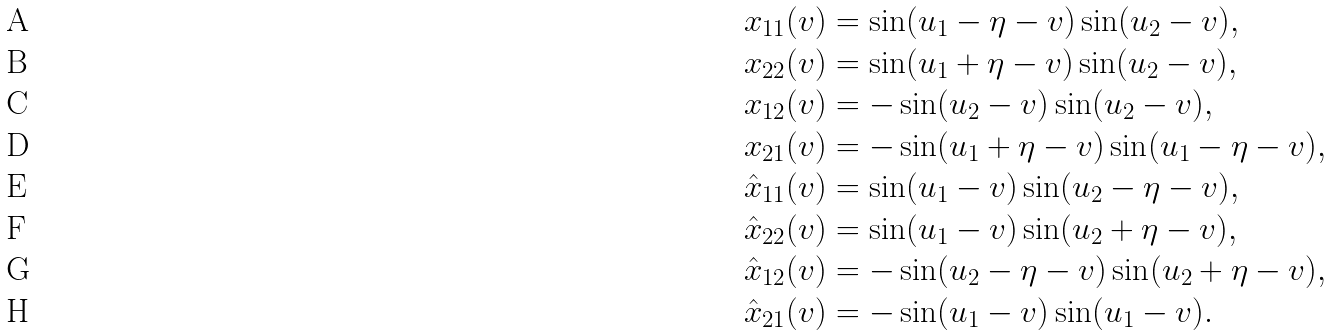<formula> <loc_0><loc_0><loc_500><loc_500>& x _ { 1 1 } ( v ) = \sin ( u _ { 1 } - \eta - v ) \sin ( u _ { 2 } - v ) , \\ & x _ { 2 2 } ( v ) = \sin ( u _ { 1 } + \eta - v ) \sin ( u _ { 2 } - v ) , \\ & x _ { 1 2 } ( v ) = - \sin ( u _ { 2 } - v ) \sin ( u _ { 2 } - v ) , \\ & x _ { 2 1 } ( v ) = - \sin ( u _ { 1 } + \eta - v ) \sin ( u _ { 1 } - \eta - v ) , \\ & \hat { x } _ { 1 1 } ( v ) = \sin ( u _ { 1 } - v ) \sin ( u _ { 2 } - \eta - v ) , \\ & \hat { x } _ { 2 2 } ( v ) = \sin ( u _ { 1 } - v ) \sin ( u _ { 2 } + \eta - v ) , \\ & \hat { x } _ { 1 2 } ( v ) = - \sin ( u _ { 2 } - \eta - v ) \sin ( u _ { 2 } + \eta - v ) , \\ & \hat { x } _ { 2 1 } ( v ) = - \sin ( u _ { 1 } - v ) \sin ( u _ { 1 } - v ) .</formula> 